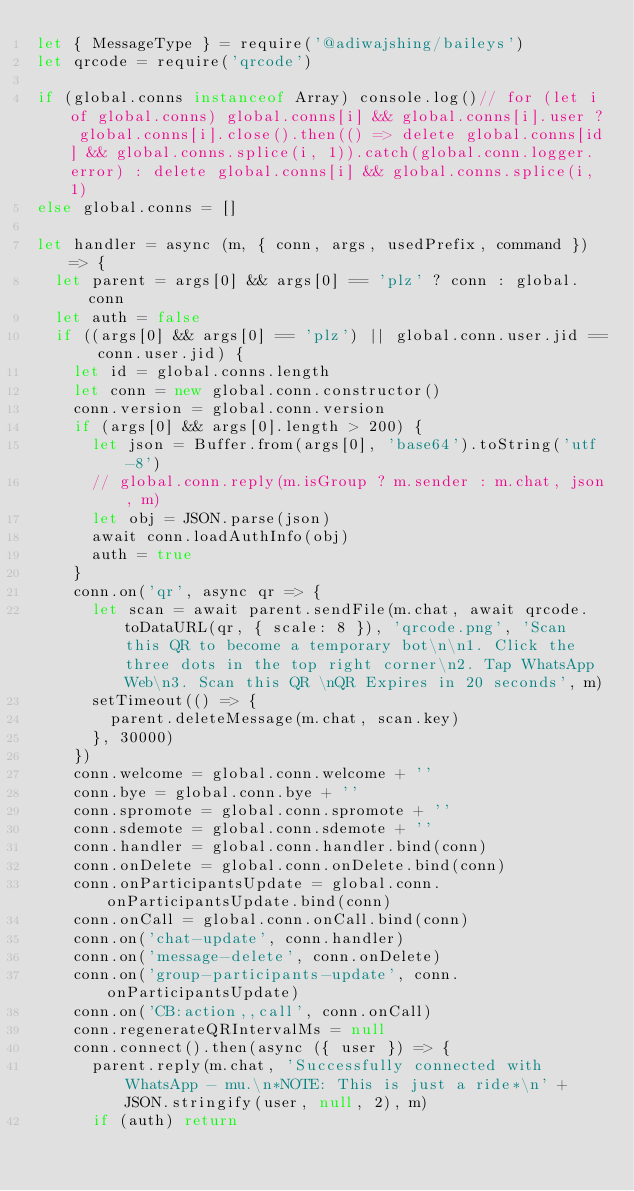<code> <loc_0><loc_0><loc_500><loc_500><_JavaScript_>let { MessageType } = require('@adiwajshing/baileys')
let qrcode = require('qrcode')

if (global.conns instanceof Array) console.log()// for (let i of global.conns) global.conns[i] && global.conns[i].user ? global.conns[i].close().then(() => delete global.conns[id] && global.conns.splice(i, 1)).catch(global.conn.logger.error) : delete global.conns[i] && global.conns.splice(i, 1)
else global.conns = []

let handler = async (m, { conn, args, usedPrefix, command }) => {
  let parent = args[0] && args[0] == 'plz' ? conn : global.conn
  let auth = false
  if ((args[0] && args[0] == 'plz') || global.conn.user.jid == conn.user.jid) {
    let id = global.conns.length
    let conn = new global.conn.constructor()
    conn.version = global.conn.version
    if (args[0] && args[0].length > 200) {
      let json = Buffer.from(args[0], 'base64').toString('utf-8')
      // global.conn.reply(m.isGroup ? m.sender : m.chat, json, m)
      let obj = JSON.parse(json)
      await conn.loadAuthInfo(obj)
      auth = true
    }
    conn.on('qr', async qr => {
      let scan = await parent.sendFile(m.chat, await qrcode.toDataURL(qr, { scale: 8 }), 'qrcode.png', 'Scan this QR to become a temporary bot\n\n1. Click the three dots in the top right corner\n2. Tap WhatsApp Web\n3. Scan this QR \nQR Expires in 20 seconds', m)
      setTimeout(() => {
        parent.deleteMessage(m.chat, scan.key)
      }, 30000)
    })
    conn.welcome = global.conn.welcome + ''
    conn.bye = global.conn.bye + ''
    conn.spromote = global.conn.spromote + ''
    conn.sdemote = global.conn.sdemote + ''
    conn.handler = global.conn.handler.bind(conn)
    conn.onDelete = global.conn.onDelete.bind(conn)
    conn.onParticipantsUpdate = global.conn.onParticipantsUpdate.bind(conn)
    conn.onCall = global.conn.onCall.bind(conn)
    conn.on('chat-update', conn.handler)
    conn.on('message-delete', conn.onDelete)
    conn.on('group-participants-update', conn.onParticipantsUpdate)
    conn.on('CB:action,,call', conn.onCall)
    conn.regenerateQRIntervalMs = null
    conn.connect().then(async ({ user }) => {
      parent.reply(m.chat, 'Successfully connected with WhatsApp - mu.\n*NOTE: This is just a ride*\n' + JSON.stringify(user, null, 2), m)
      if (auth) return</code> 